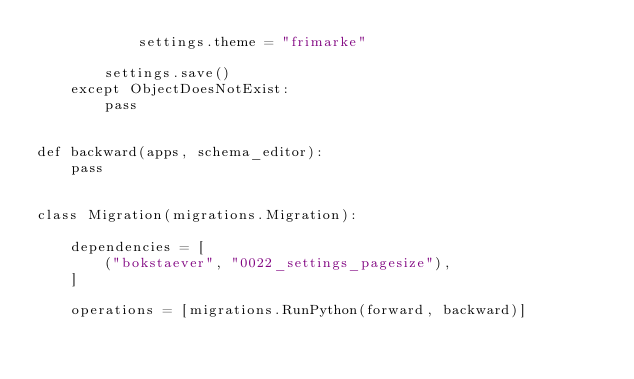<code> <loc_0><loc_0><loc_500><loc_500><_Python_>            settings.theme = "frimarke"

        settings.save()
    except ObjectDoesNotExist:
        pass


def backward(apps, schema_editor):
    pass


class Migration(migrations.Migration):

    dependencies = [
        ("bokstaever", "0022_settings_pagesize"),
    ]

    operations = [migrations.RunPython(forward, backward)]
</code> 